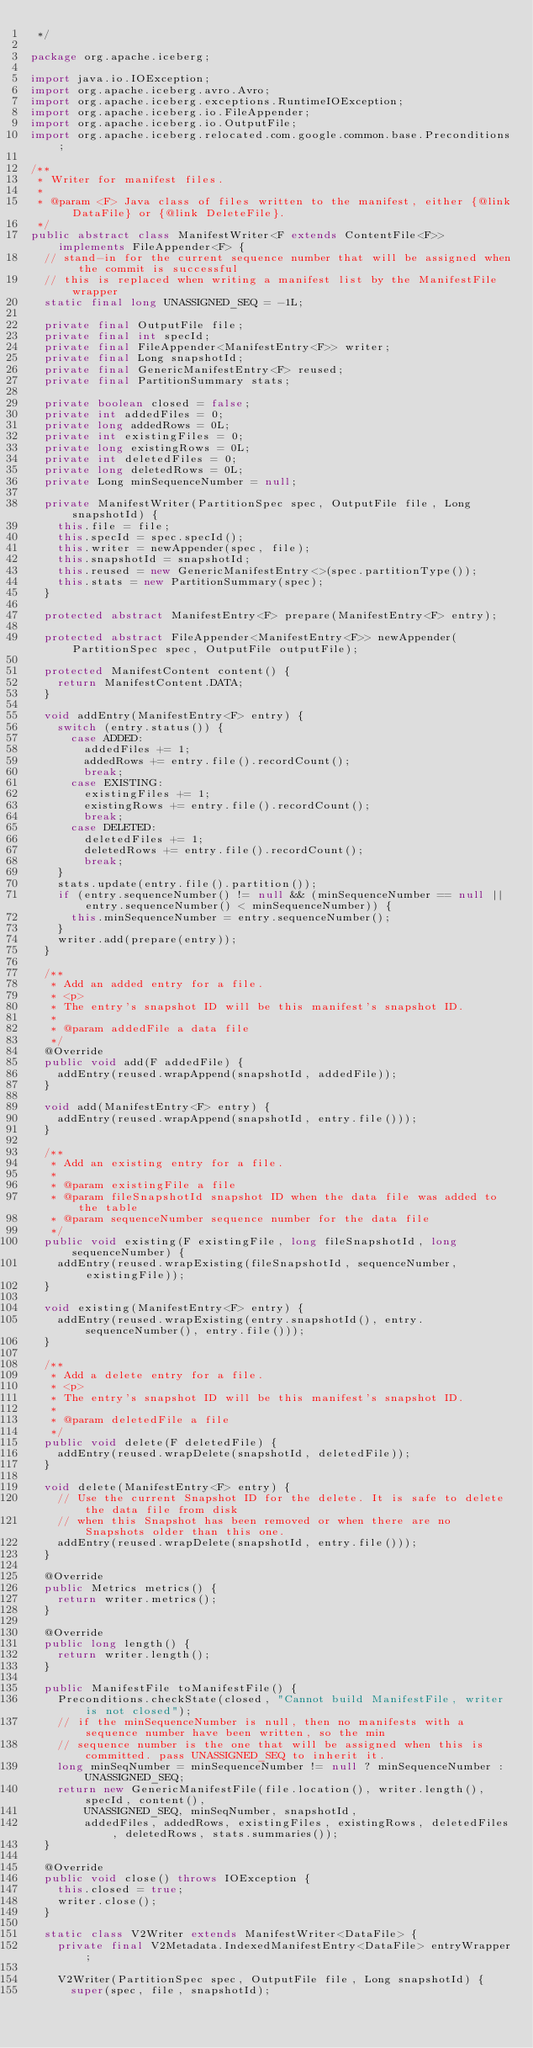<code> <loc_0><loc_0><loc_500><loc_500><_Java_> */

package org.apache.iceberg;

import java.io.IOException;
import org.apache.iceberg.avro.Avro;
import org.apache.iceberg.exceptions.RuntimeIOException;
import org.apache.iceberg.io.FileAppender;
import org.apache.iceberg.io.OutputFile;
import org.apache.iceberg.relocated.com.google.common.base.Preconditions;

/**
 * Writer for manifest files.
 *
 * @param <F> Java class of files written to the manifest, either {@link DataFile} or {@link DeleteFile}.
 */
public abstract class ManifestWriter<F extends ContentFile<F>> implements FileAppender<F> {
  // stand-in for the current sequence number that will be assigned when the commit is successful
  // this is replaced when writing a manifest list by the ManifestFile wrapper
  static final long UNASSIGNED_SEQ = -1L;

  private final OutputFile file;
  private final int specId;
  private final FileAppender<ManifestEntry<F>> writer;
  private final Long snapshotId;
  private final GenericManifestEntry<F> reused;
  private final PartitionSummary stats;

  private boolean closed = false;
  private int addedFiles = 0;
  private long addedRows = 0L;
  private int existingFiles = 0;
  private long existingRows = 0L;
  private int deletedFiles = 0;
  private long deletedRows = 0L;
  private Long minSequenceNumber = null;

  private ManifestWriter(PartitionSpec spec, OutputFile file, Long snapshotId) {
    this.file = file;
    this.specId = spec.specId();
    this.writer = newAppender(spec, file);
    this.snapshotId = snapshotId;
    this.reused = new GenericManifestEntry<>(spec.partitionType());
    this.stats = new PartitionSummary(spec);
  }

  protected abstract ManifestEntry<F> prepare(ManifestEntry<F> entry);

  protected abstract FileAppender<ManifestEntry<F>> newAppender(PartitionSpec spec, OutputFile outputFile);

  protected ManifestContent content() {
    return ManifestContent.DATA;
  }

  void addEntry(ManifestEntry<F> entry) {
    switch (entry.status()) {
      case ADDED:
        addedFiles += 1;
        addedRows += entry.file().recordCount();
        break;
      case EXISTING:
        existingFiles += 1;
        existingRows += entry.file().recordCount();
        break;
      case DELETED:
        deletedFiles += 1;
        deletedRows += entry.file().recordCount();
        break;
    }
    stats.update(entry.file().partition());
    if (entry.sequenceNumber() != null && (minSequenceNumber == null || entry.sequenceNumber() < minSequenceNumber)) {
      this.minSequenceNumber = entry.sequenceNumber();
    }
    writer.add(prepare(entry));
  }

  /**
   * Add an added entry for a file.
   * <p>
   * The entry's snapshot ID will be this manifest's snapshot ID.
   *
   * @param addedFile a data file
   */
  @Override
  public void add(F addedFile) {
    addEntry(reused.wrapAppend(snapshotId, addedFile));
  }

  void add(ManifestEntry<F> entry) {
    addEntry(reused.wrapAppend(snapshotId, entry.file()));
  }

  /**
   * Add an existing entry for a file.
   *
   * @param existingFile a file
   * @param fileSnapshotId snapshot ID when the data file was added to the table
   * @param sequenceNumber sequence number for the data file
   */
  public void existing(F existingFile, long fileSnapshotId, long sequenceNumber) {
    addEntry(reused.wrapExisting(fileSnapshotId, sequenceNumber, existingFile));
  }

  void existing(ManifestEntry<F> entry) {
    addEntry(reused.wrapExisting(entry.snapshotId(), entry.sequenceNumber(), entry.file()));
  }

  /**
   * Add a delete entry for a file.
   * <p>
   * The entry's snapshot ID will be this manifest's snapshot ID.
   *
   * @param deletedFile a file
   */
  public void delete(F deletedFile) {
    addEntry(reused.wrapDelete(snapshotId, deletedFile));
  }

  void delete(ManifestEntry<F> entry) {
    // Use the current Snapshot ID for the delete. It is safe to delete the data file from disk
    // when this Snapshot has been removed or when there are no Snapshots older than this one.
    addEntry(reused.wrapDelete(snapshotId, entry.file()));
  }

  @Override
  public Metrics metrics() {
    return writer.metrics();
  }

  @Override
  public long length() {
    return writer.length();
  }

  public ManifestFile toManifestFile() {
    Preconditions.checkState(closed, "Cannot build ManifestFile, writer is not closed");
    // if the minSequenceNumber is null, then no manifests with a sequence number have been written, so the min
    // sequence number is the one that will be assigned when this is committed. pass UNASSIGNED_SEQ to inherit it.
    long minSeqNumber = minSequenceNumber != null ? minSequenceNumber : UNASSIGNED_SEQ;
    return new GenericManifestFile(file.location(), writer.length(), specId, content(),
        UNASSIGNED_SEQ, minSeqNumber, snapshotId,
        addedFiles, addedRows, existingFiles, existingRows, deletedFiles, deletedRows, stats.summaries());
  }

  @Override
  public void close() throws IOException {
    this.closed = true;
    writer.close();
  }

  static class V2Writer extends ManifestWriter<DataFile> {
    private final V2Metadata.IndexedManifestEntry<DataFile> entryWrapper;

    V2Writer(PartitionSpec spec, OutputFile file, Long snapshotId) {
      super(spec, file, snapshotId);</code> 